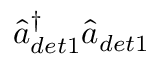<formula> <loc_0><loc_0><loc_500><loc_500>\hat { a } _ { d e t 1 } ^ { \dagger } \hat { a } _ { d e t 1 }</formula> 